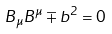<formula> <loc_0><loc_0><loc_500><loc_500>B _ { \mu } B ^ { \mu } \mp b ^ { 2 } = 0</formula> 